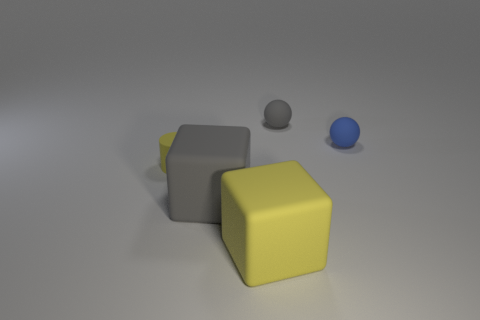Add 5 brown cylinders. How many objects exist? 10 Subtract all spheres. How many objects are left? 3 Subtract all small yellow matte cylinders. Subtract all matte blocks. How many objects are left? 2 Add 3 rubber cylinders. How many rubber cylinders are left? 4 Add 4 large cyan things. How many large cyan things exist? 4 Subtract 0 red cylinders. How many objects are left? 5 